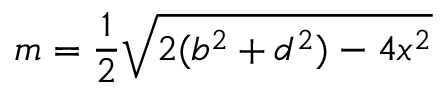<formula> <loc_0><loc_0><loc_500><loc_500>m = { \frac { 1 } { 2 } } { \sqrt { 2 ( b ^ { 2 } + d ^ { 2 } ) - 4 x ^ { 2 } } }</formula> 